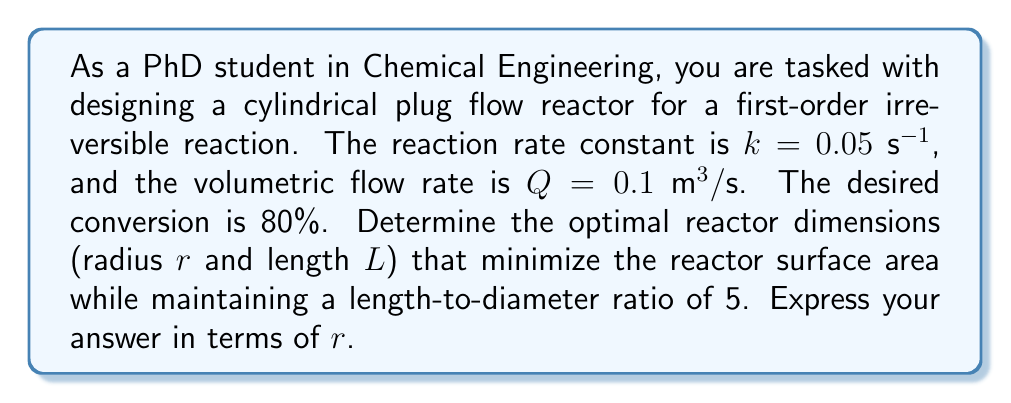Give your solution to this math problem. Let's approach this step-by-step:

1) For a first-order reaction in a plug flow reactor, the relationship between conversion ($X$) and residence time ($\tau$) is:

   $$X = 1 - e^{-k\tau}$$

2) Solving for $\tau$ given $X = 0.8$:

   $$0.8 = 1 - e^{-0.05\tau}$$
   $$e^{-0.05\tau} = 0.2$$
   $$-0.05\tau = \ln(0.2)$$
   $$\tau = -\frac{\ln(0.2)}{0.05} = 32.19 \text{ s}$$

3) The reactor volume $V$ is related to $\tau$ and $Q$:

   $$V = Q\tau = 0.1 \cdot 32.19 = 3.219 \text{ m}^3$$

4) For a cylindrical reactor:

   $$V = \pi r^2 L$$

5) Given the length-to-diameter ratio of 5:

   $$L = 10r$$

6) Substituting this into the volume equation:

   $$3.219 = \pi r^2 (10r)$$
   $$3.219 = 10\pi r^3$$
   $$r = \sqrt[3]{\frac{3.219}{10\pi}} = 0.5 \text{ m}$$

7) The length is then:

   $$L = 10r = 10 \cdot 0.5 = 5 \text{ m}$$

8) To express $L$ in terms of $r$:

   $$L = 10r$$
Answer: The optimal reactor dimensions are:
Radius: $r = 0.5 \text{ m}$
Length: $L = 10r = 5 \text{ m}$ 